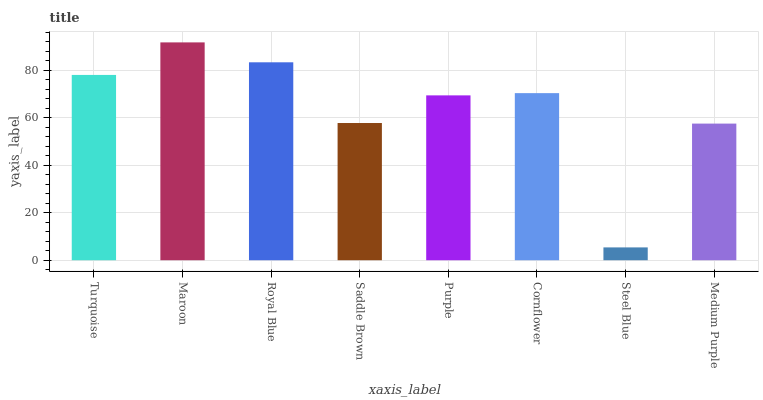Is Steel Blue the minimum?
Answer yes or no. Yes. Is Maroon the maximum?
Answer yes or no. Yes. Is Royal Blue the minimum?
Answer yes or no. No. Is Royal Blue the maximum?
Answer yes or no. No. Is Maroon greater than Royal Blue?
Answer yes or no. Yes. Is Royal Blue less than Maroon?
Answer yes or no. Yes. Is Royal Blue greater than Maroon?
Answer yes or no. No. Is Maroon less than Royal Blue?
Answer yes or no. No. Is Cornflower the high median?
Answer yes or no. Yes. Is Purple the low median?
Answer yes or no. Yes. Is Turquoise the high median?
Answer yes or no. No. Is Cornflower the low median?
Answer yes or no. No. 